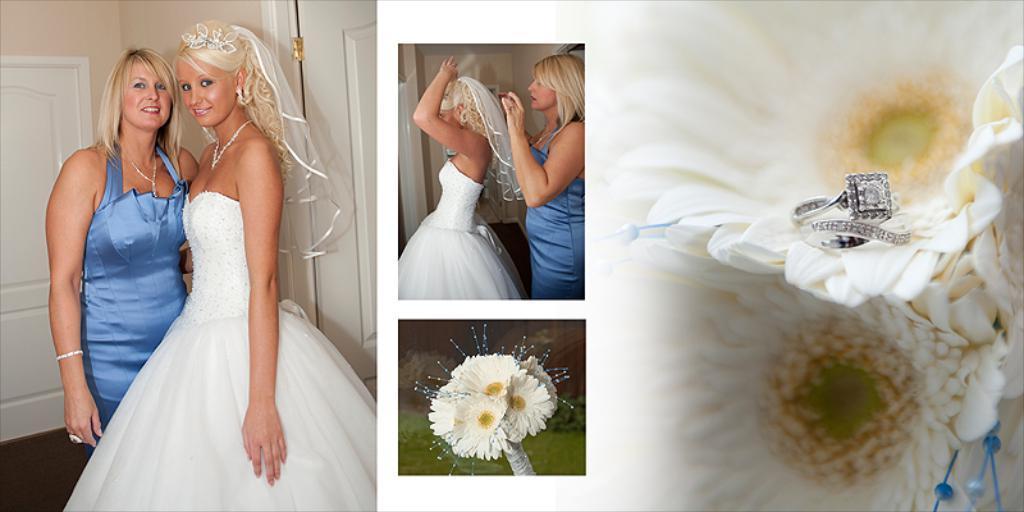How would you summarize this image in a sentence or two? Collage picture. In this picture we can see people, flowers, doors and wall. On this flower there is a ring. 